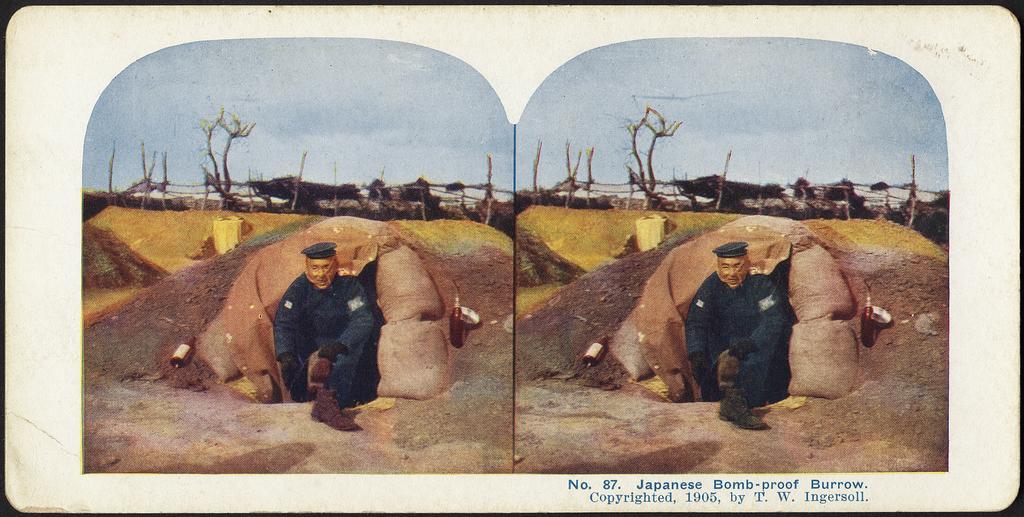Can you describe this image briefly? In this image I can see depiction picture and I can also see same picture on the both side of this image. On the bottom right side of this image I can see something is written. 